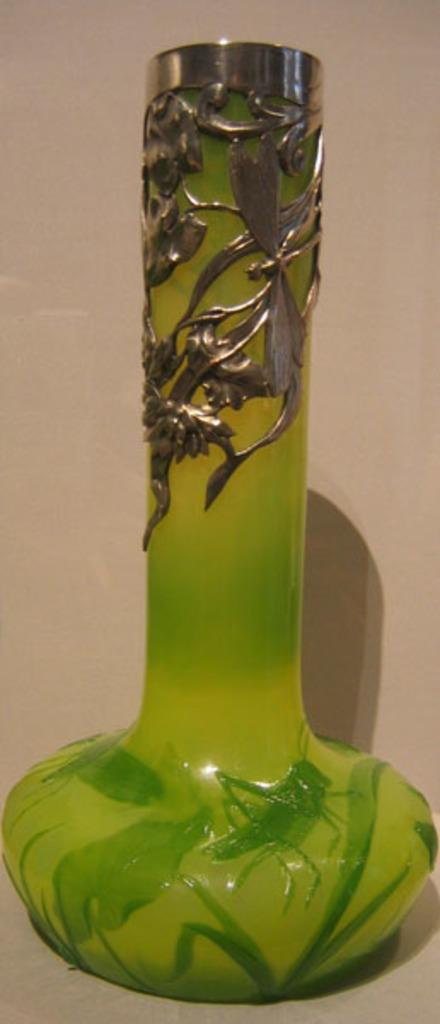What object is present in the image that is made of glass? There is a glass bottle in the image. Where is the glass bottle located? The glass bottle is on a platform. What type of haircut is the glass bottle getting in the image? There is no haircut or person present in the image, so it is not possible to answer that question. 